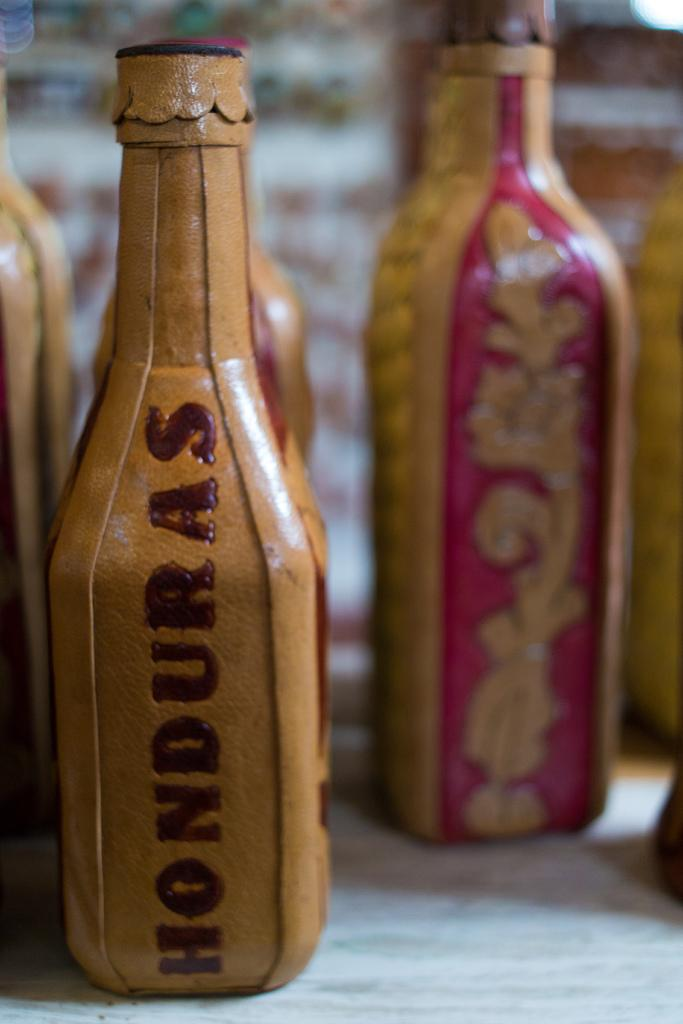<image>
Offer a succinct explanation of the picture presented. Brown bottle with the words Honduras on it. 